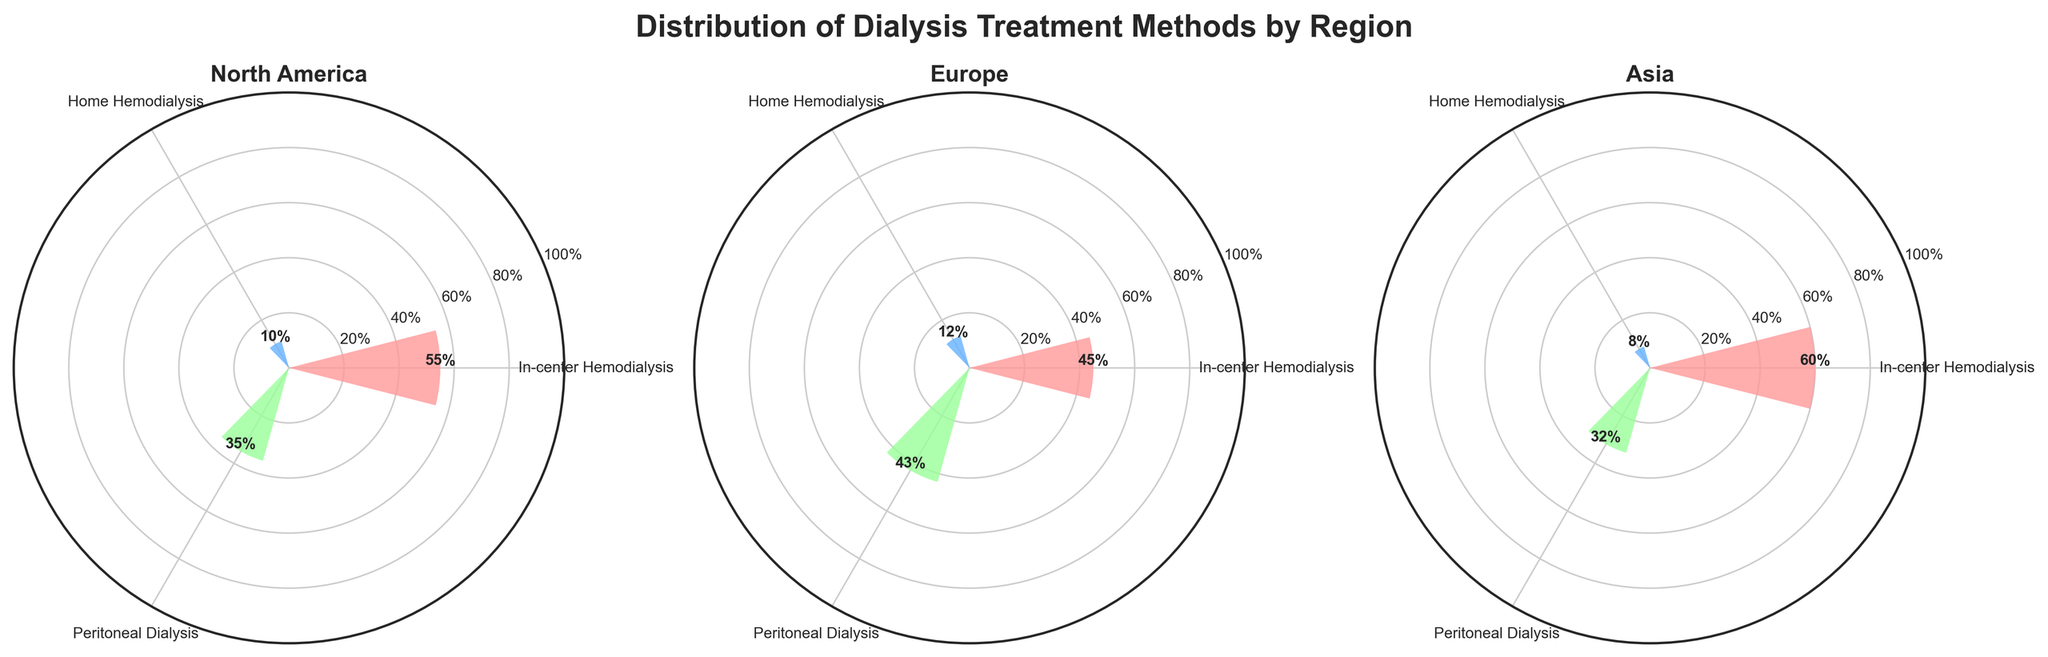What is the most common dialysis treatment method in North America? By observing the North America subplot, the theta angle indicates that In-center Hemodialysis has the highest frequency bar with a radii of 55%.
Answer: In-center Hemodialysis Which dialysis treatment method has the lowest percentage in Asia? Looking at the Asia subplot, Home Hemodialysis has the shortest bar with a radii of 8%.
Answer: Home Hemodialysis How does the percentage of Peritoneal Dialysis compare between North America and Europe? In the subplots for North America and Europe, Peritoneal Dialysis shows radii of 35% and 43%, respectively, indicating that Europe has a higher percentage than North America.
Answer: Europe > North America What's the difference in the percentage of In-center Hemodialysis in North America and Asia? Checking the subplots for In-center Hemodialysis in North America and Asia, the radii are 55% and 60%, respectively. The difference is 60% - 55%.
Answer: 5% Which region has the highest percentage for Home Hemodialysis? Looking at the subplots for North America, Europe, and Asia, the radii for Home Hemodialysis are 10%, 12%, and 8% respectively, indicating that Europe has the highest percentage.
Answer: Europe What is the combined percentage of Peritoneal Dialysis in all regions? Adding up the radii for Peritoneal Dialysis from North America, Europe, and Asia subplots, we get 35% + 43% + 32% = 110%.
Answer: 110% Between which regions is the percentage of In-center Hemodialysis most similar? Comparing the radii of In-center Hemodialysis in North America (55%), Europe (45%) and Asia (60%), the North America and Asia percentages are the closest to each other.
Answer: North America and Asia What is the average percentage of Home Hemodialysis across all regions? Adding the radii for Home Hemodialysis across North America, Europe, and Asia gives 10% + 12% + 8%. The average is (10% + 12% + 8%)/3 = 10%.
Answer: 10% How much higher is the percentage of Peritoneal Dialysis in Europe compared to Asia? Comparing Peritoneal Dialysis in Europe (43%) to Asia (32%), the difference is 43% - 32%.
Answer: 11% 